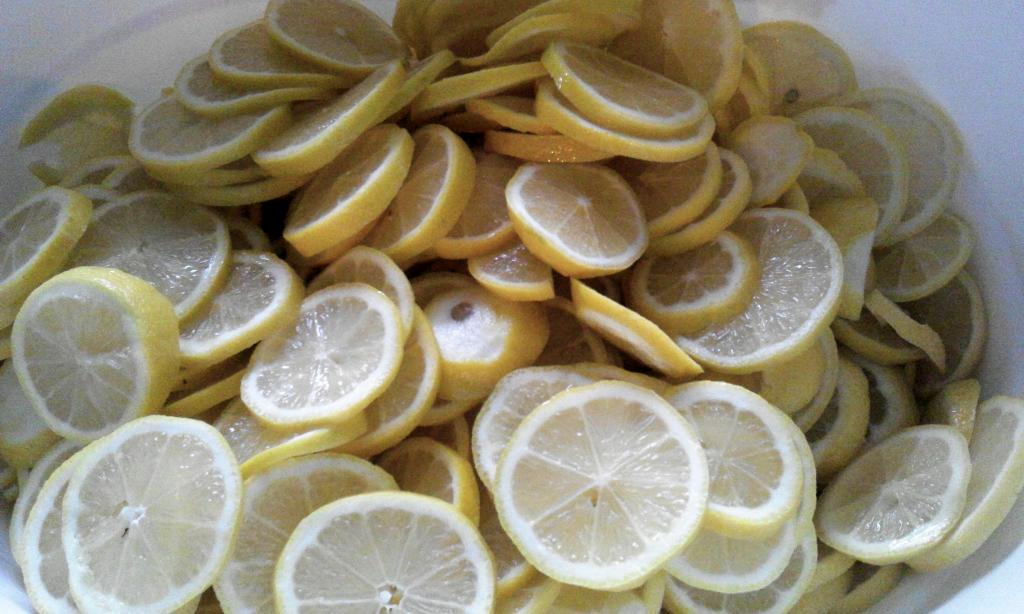What type of fruit can be seen in the image? There are slices of lemons in the image. How are the lemons presented in the image? The lemons are sliced. What type of pollution can be seen coming from the crook's hands in the image? There is no crook or pollution present in the image; it only features slices of lemons. 